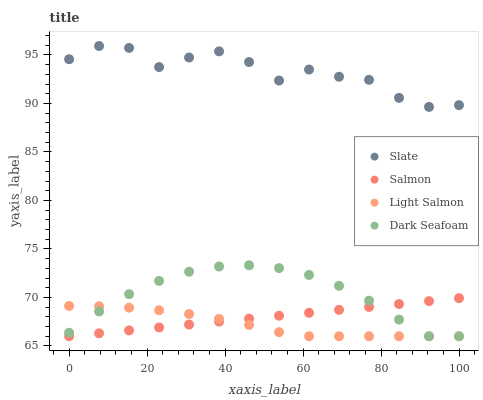Does Light Salmon have the minimum area under the curve?
Answer yes or no. Yes. Does Slate have the maximum area under the curve?
Answer yes or no. Yes. Does Salmon have the minimum area under the curve?
Answer yes or no. No. Does Salmon have the maximum area under the curve?
Answer yes or no. No. Is Salmon the smoothest?
Answer yes or no. Yes. Is Slate the roughest?
Answer yes or no. Yes. Is Light Salmon the smoothest?
Answer yes or no. No. Is Light Salmon the roughest?
Answer yes or no. No. Does Salmon have the lowest value?
Answer yes or no. Yes. Does Slate have the highest value?
Answer yes or no. Yes. Does Salmon have the highest value?
Answer yes or no. No. Is Light Salmon less than Slate?
Answer yes or no. Yes. Is Slate greater than Dark Seafoam?
Answer yes or no. Yes. Does Dark Seafoam intersect Salmon?
Answer yes or no. Yes. Is Dark Seafoam less than Salmon?
Answer yes or no. No. Is Dark Seafoam greater than Salmon?
Answer yes or no. No. Does Light Salmon intersect Slate?
Answer yes or no. No. 